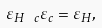<formula> <loc_0><loc_0><loc_500><loc_500>\varepsilon _ { H \ c } \varepsilon _ { c } = \varepsilon _ { H } ,</formula> 